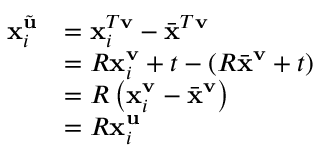Convert formula to latex. <formula><loc_0><loc_0><loc_500><loc_500>\begin{array} { r l } { x _ { i } ^ { \tilde { u } } } & { = x _ { i } ^ { T v } - \bar { x } ^ { T v } } \\ & { = R x _ { i } ^ { v } + t - ( R \bar { x } ^ { v } + t ) } \\ & { = R \left ( x _ { i } ^ { v } - \bar { x } ^ { v } \right ) } \\ & { = R x _ { i } ^ { u } } \end{array}</formula> 